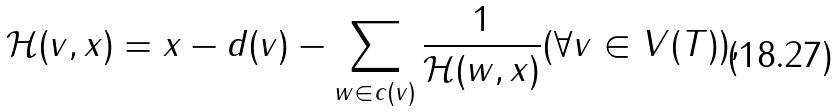Convert formula to latex. <formula><loc_0><loc_0><loc_500><loc_500>\mathcal { H } ( v , x ) & = x - d ( v ) - \sum _ { w \in c ( v ) } \frac { 1 } { \mathcal { H } ( w , x ) } ( \forall v \in V ( T ) ) ,</formula> 